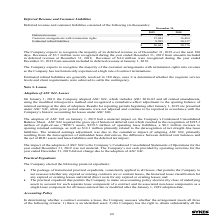According to Sykes Enterprises Incorporated's financial document, Why does the Company expect to recognize the majority of the customer arrangements with termination rights into revenue? as the Company has not historically experienced a high rate of contract terminations.. The document states: "arrangements with termination rights into revenue as the Company has not historically experienced a high rate of contract terminations...." Also, How long do the estimated refund liabilities take to be generally resolved? 180 days, once it is determined whether the requisite service levels and client requirements were achieved to settle the contingency.. The document states: "mated refund liabilities are generally resolved in 180 days, once it is determined whether the requisite service levels and client requirements were a..." Also, What are the different types of components making up the deferred revenue and customer liabilities? The document contains multiple relevant values: Deferred revenue, Customer arrangements with termination rights, Estimated refund liabilities. From the document: "Estimated refund liabilities 8,585 10,117 Deferred Revenue and Customer Liabilities Customer arrangements with termination rights 15,024 16,404..." Additionally, In which year was deferred revenue larger? According to the financial document, 2018. The relevant text states: "2019 2018..." Also, can you calculate: What was the change in deferred revenue in 2019 from 2018? Based on the calculation: 3,012-3,655, the result is -643 (in thousands). This is based on the information: "Deferred revenue $ 3,012 $ 3,655 Deferred revenue $ 3,012 $ 3,655..." The key data points involved are: 3,012, 3,655. Also, can you calculate: What was the percentage change in deferred revenue in 2019 from 2018? To answer this question, I need to perform calculations using the financial data. The calculation is: (3,012-3,655)/3,655, which equals -17.59 (percentage). This is based on the information: "Deferred revenue $ 3,012 $ 3,655 Deferred revenue $ 3,012 $ 3,655..." The key data points involved are: 3,012, 3,655. 